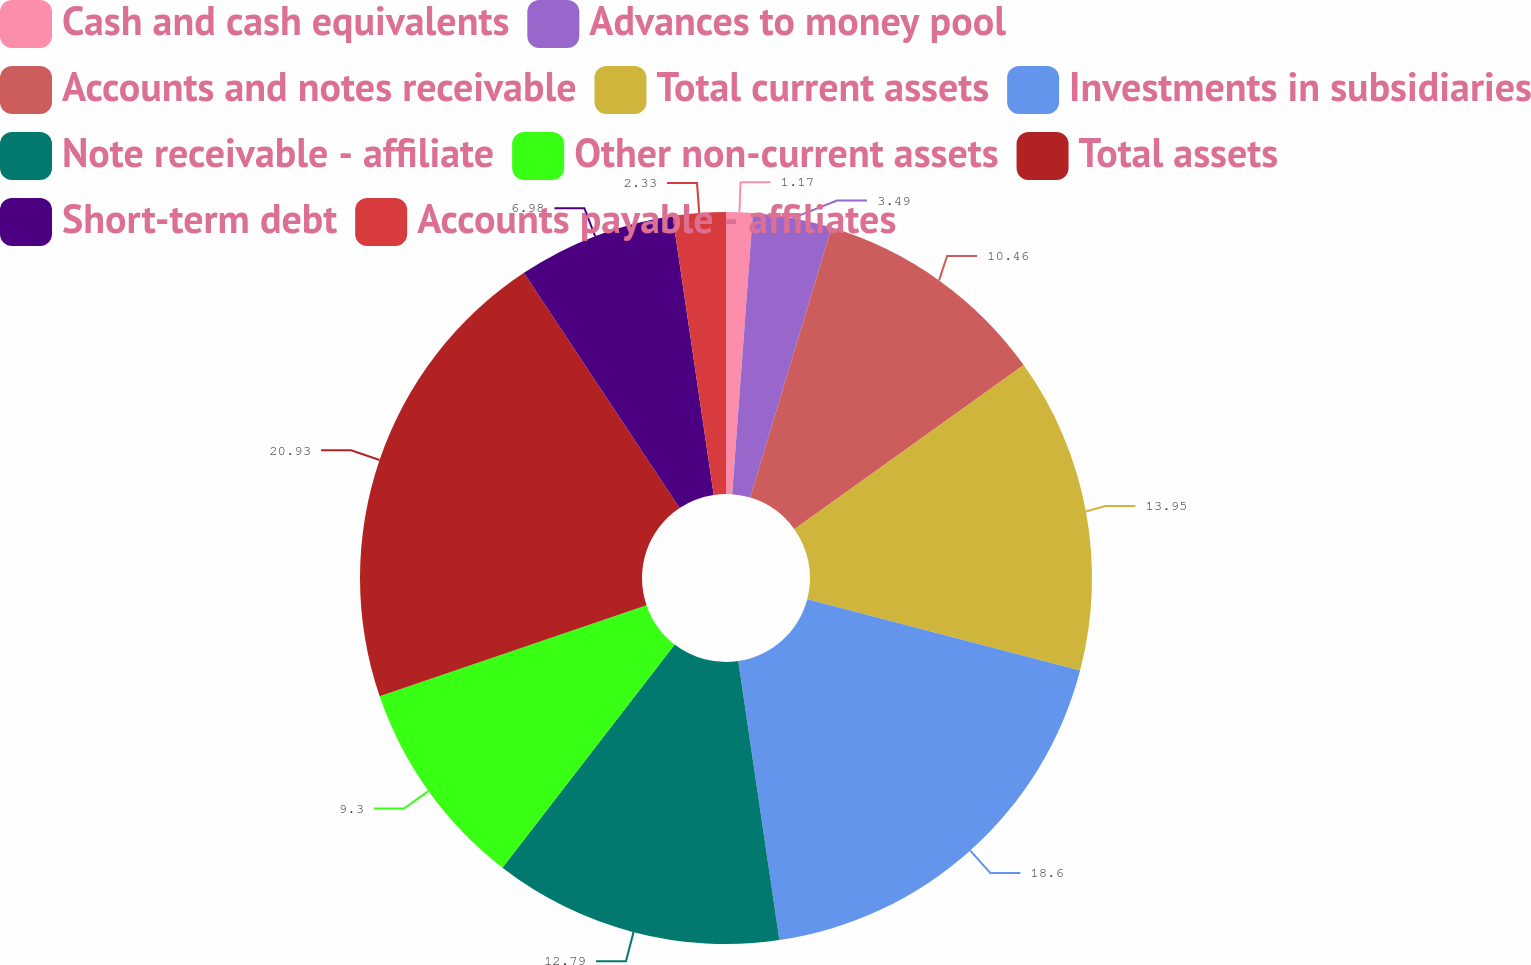<chart> <loc_0><loc_0><loc_500><loc_500><pie_chart><fcel>Cash and cash equivalents<fcel>Advances to money pool<fcel>Accounts and notes receivable<fcel>Total current assets<fcel>Investments in subsidiaries<fcel>Note receivable - affiliate<fcel>Other non-current assets<fcel>Total assets<fcel>Short-term debt<fcel>Accounts payable - affiliates<nl><fcel>1.17%<fcel>3.49%<fcel>10.46%<fcel>13.95%<fcel>18.6%<fcel>12.79%<fcel>9.3%<fcel>20.93%<fcel>6.98%<fcel>2.33%<nl></chart> 